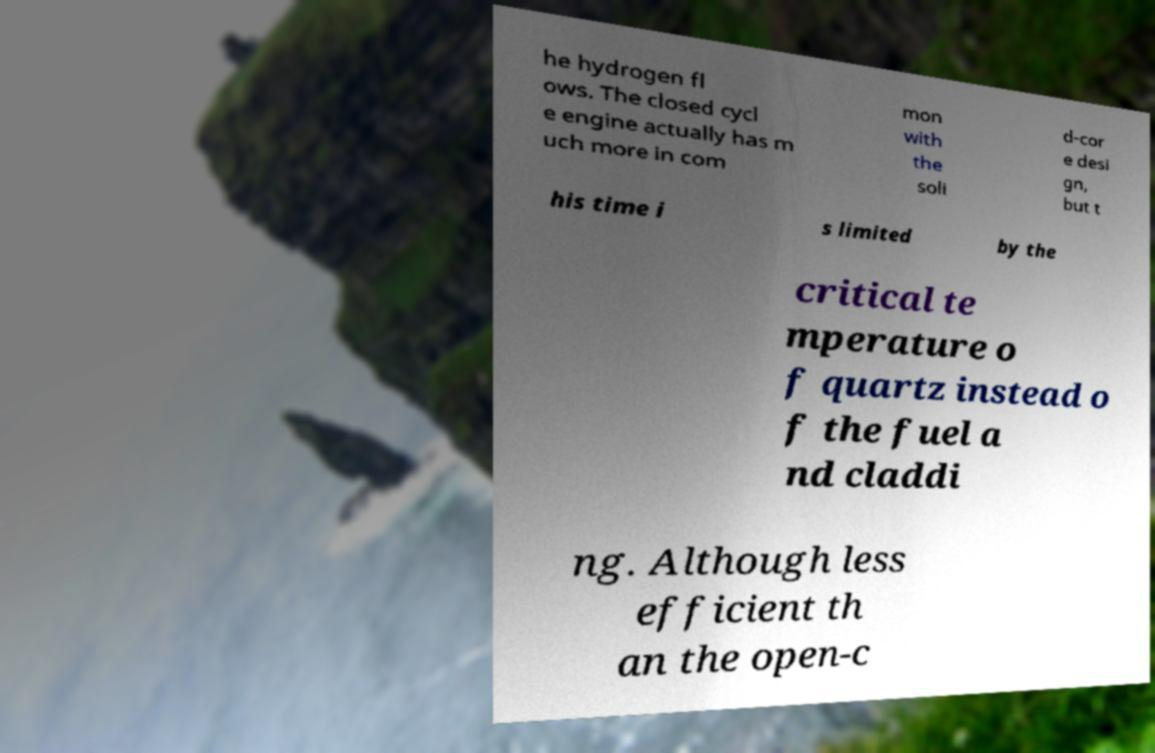Please read and relay the text visible in this image. What does it say? he hydrogen fl ows. The closed cycl e engine actually has m uch more in com mon with the soli d-cor e desi gn, but t his time i s limited by the critical te mperature o f quartz instead o f the fuel a nd claddi ng. Although less efficient th an the open-c 